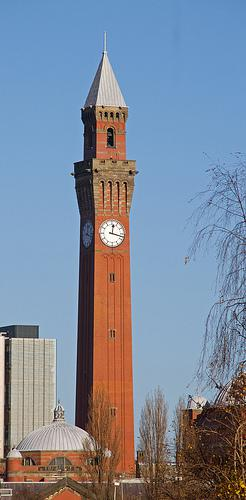Question: what has branches that enter the right side of the photo?
Choices:
A. Bush.
B. Tree.
C. Plant.
D. Flower.
Answer with the letter. Answer: B Question: what are the circular shapes on the tower?
Choices:
A. Clocks.
B. Windows.
C. Sculptures.
D. Architect.
Answer with the letter. Answer: A Question: what color is the sky?
Choices:
A. Gray.
B. Purple.
C. Black.
D. Blue.
Answer with the letter. Answer: D Question: what is the tallest object in this photo?
Choices:
A. Tree.
B. Person.
C. Truck.
D. Tower.
Answer with the letter. Answer: D Question: how many completely grey buildings are there?
Choices:
A. Two.
B. Three.
C. One.
D. Four.
Answer with the letter. Answer: C 